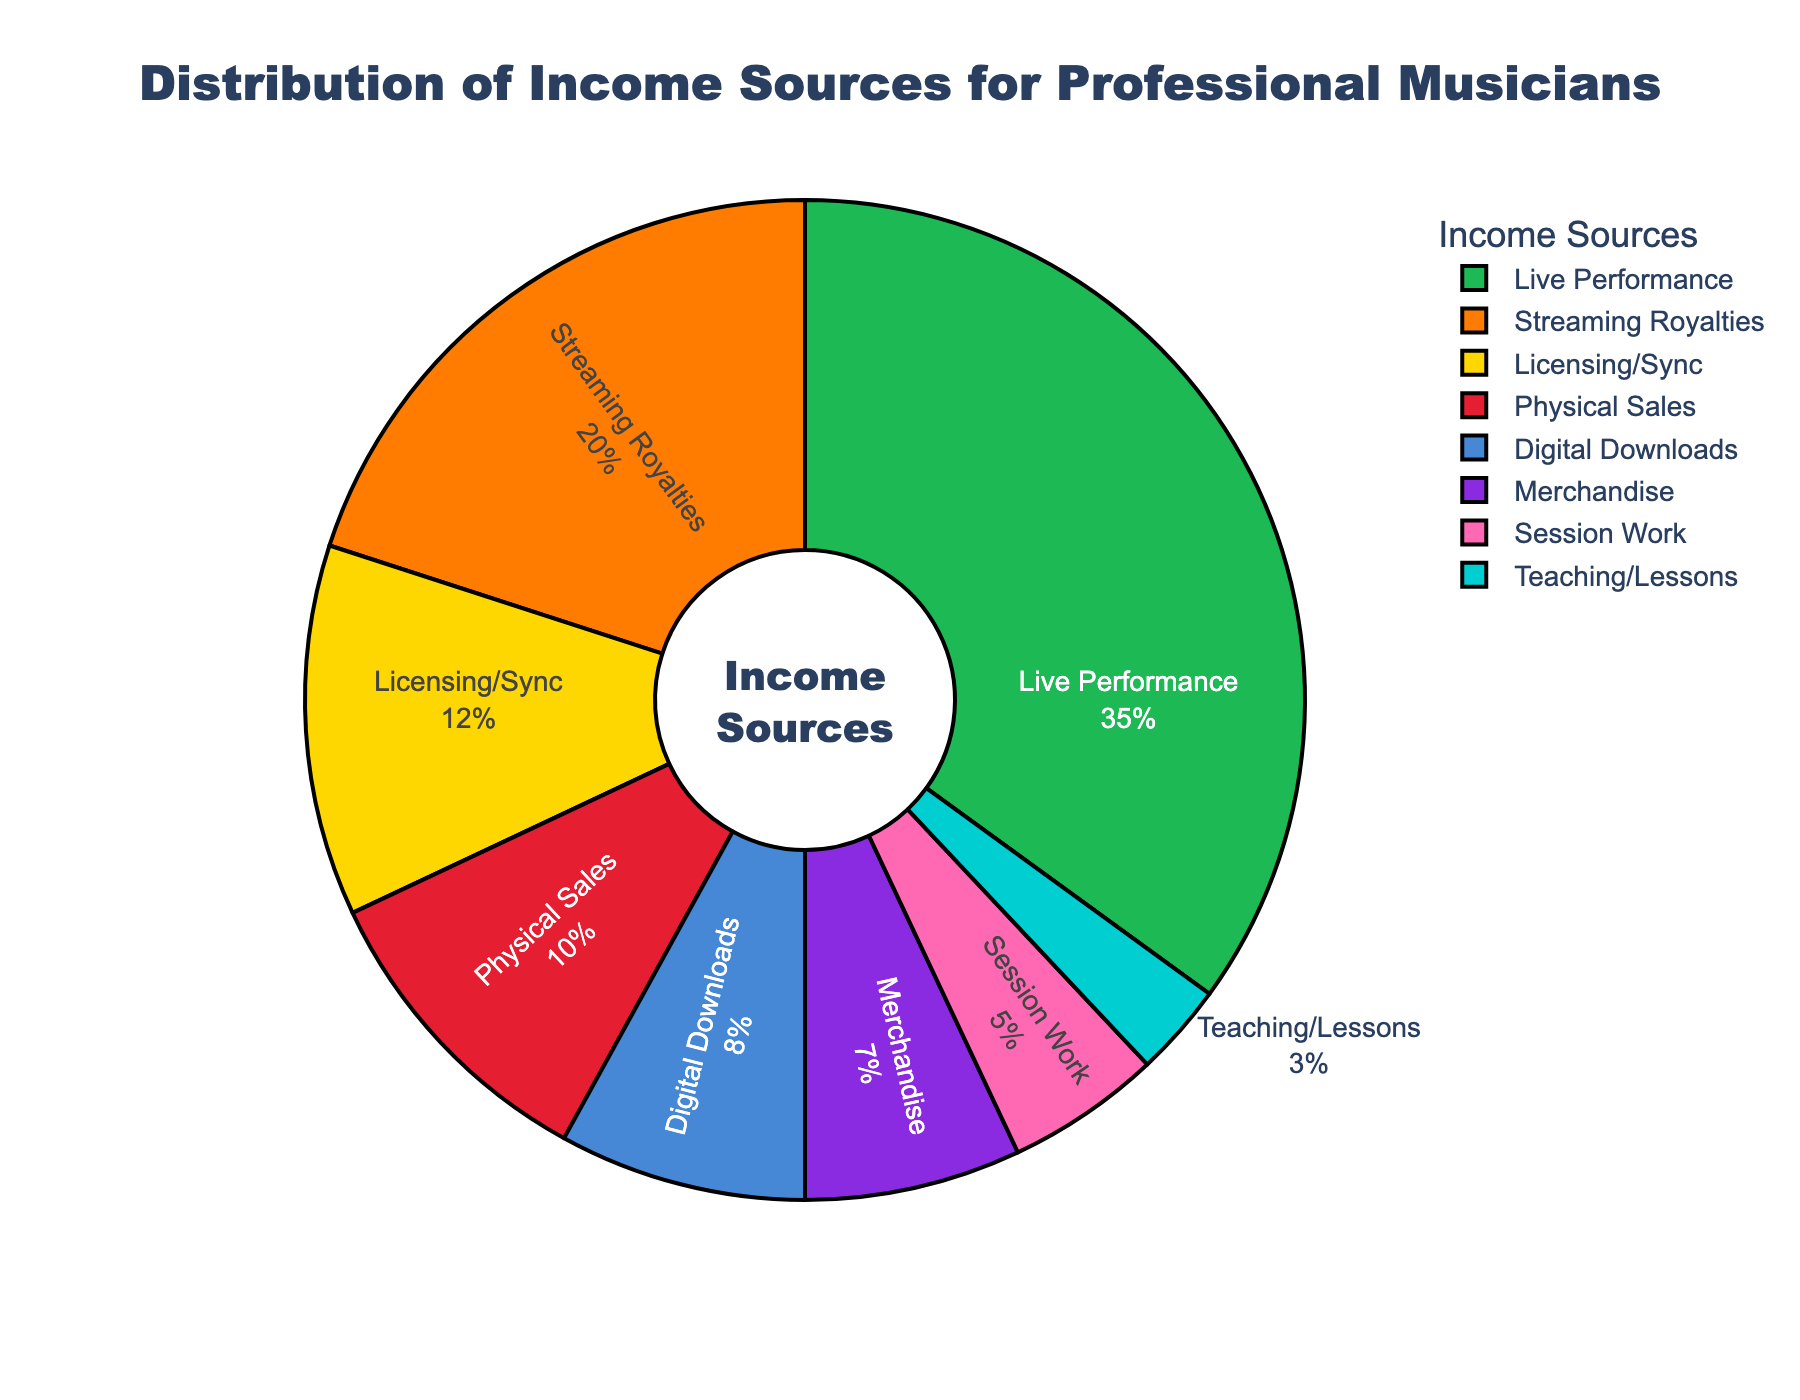What is the largest income source for professional musicians according to the pie chart? The pie chart shows different income sources, and the largest slice is labeled "Live Performance" with 35%.
Answer: Live Performance Which income source has a higher percentage: Merchandise or Teaching/Lessons? The pie chart shows the percentage for Merchandise as 7% and Teaching/Lessons as 3%. 7% is greater than 3%, so Merchandise has a higher percentage.
Answer: Merchandise What is the combined percentage of Streaming Royalties and Licensing/Sync? The pie chart shows Streaming Royalties as 20% and Licensing/Sync as 12%. Adding these together, 20% + 12% = 32%.
Answer: 32% Which income sources contribute to more than 10% of the total income? The pie chart shows the percentages for each category. The categories with more than 10% are Live Performance (35%), Streaming Royalties (20%), and Licensing/Sync (12%).
Answer: Live Performance, Streaming Royalties, Licensing/Sync Visually, which income source uses the green color in the pie chart? The pie chart uses specific colors for each slice. The green color slice represents the "Live Performance" category.
Answer: Live Performance How much greater is the percentage of Live Performance than Digital Downloads? From the pie chart, Live Performance is 35% and Digital Downloads is 8%. The difference is 35% - 8% = 27%.
Answer: 27% Rank the income sources from highest to lowest percentage according to the pie chart. The pie chart provides the percentages for each category. Arranging them from highest to lowest: Live Performance (35%), Streaming Royalties (20%), Licensing/Sync (12%), Physical Sales (10%), Digital Downloads (8%), Merchandise (7%), Session Work (5%), Teaching/Lessons (3%).
Answer: Live Performance, Streaming Royalties, Licensing/Sync, Physical Sales, Digital Downloads, Merchandise, Session Work, Teaching/Lessons Which income source contributes the least to professional musicians' income? The pie chart shows Teaching/Lessons has the smallest percentage at 3%.
Answer: Teaching/Lessons 